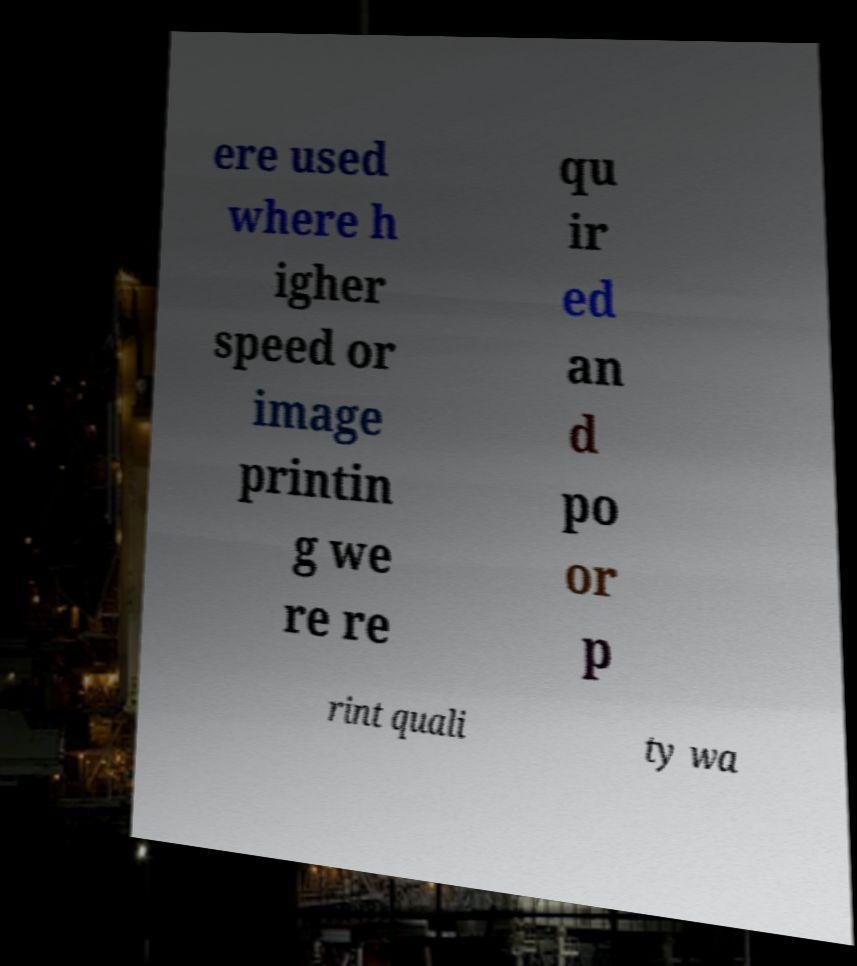Please read and relay the text visible in this image. What does it say? ere used where h igher speed or image printin g we re re qu ir ed an d po or p rint quali ty wa 